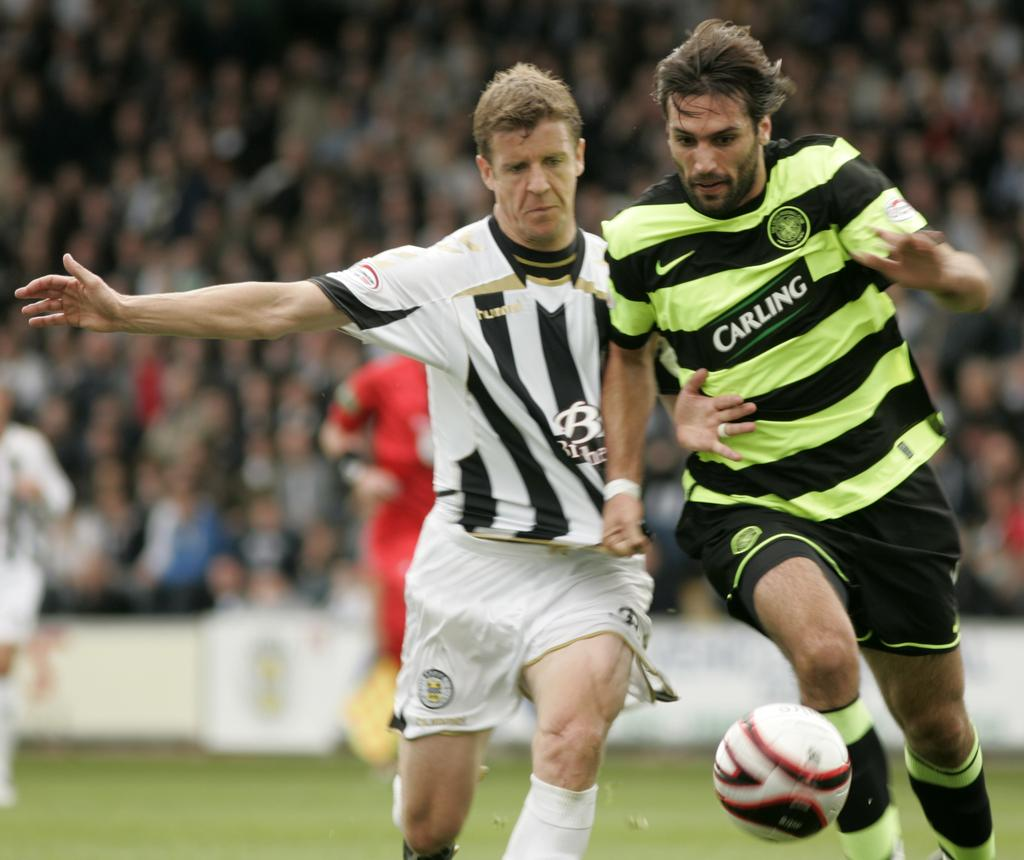How many football players are in the image? There are two football players in the image. What colors are the football players wearing? One football player is wearing a green color dress, and the other is wearing a white color dress. What object is present at the bottom of the image? There is a ball at the bottom of the image. What type of rhythm is the football player with green dress playing in the image? There is no indication of any rhythm or music in the image; it features two football players and a ball. Does the football player with white dress have long or short hair? The image does not provide any information about the hair of the football players, so it cannot be determined from the image. 